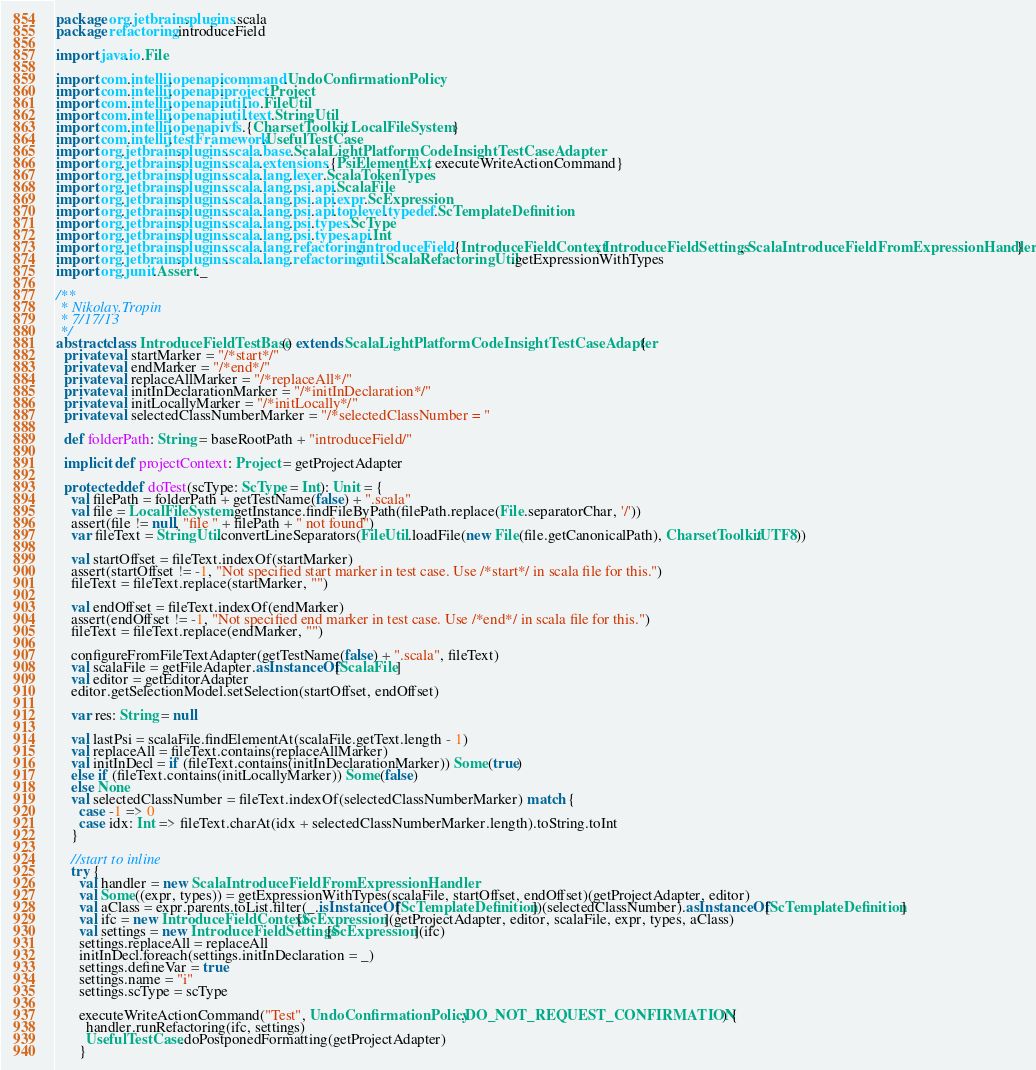Convert code to text. <code><loc_0><loc_0><loc_500><loc_500><_Scala_>package org.jetbrains.plugins.scala
package refactoring.introduceField

import java.io.File

import com.intellij.openapi.command.UndoConfirmationPolicy
import com.intellij.openapi.project.Project
import com.intellij.openapi.util.io.FileUtil
import com.intellij.openapi.util.text.StringUtil
import com.intellij.openapi.vfs.{CharsetToolkit, LocalFileSystem}
import com.intellij.testFramework.UsefulTestCase
import org.jetbrains.plugins.scala.base.ScalaLightPlatformCodeInsightTestCaseAdapter
import org.jetbrains.plugins.scala.extensions.{PsiElementExt, executeWriteActionCommand}
import org.jetbrains.plugins.scala.lang.lexer.ScalaTokenTypes
import org.jetbrains.plugins.scala.lang.psi.api.ScalaFile
import org.jetbrains.plugins.scala.lang.psi.api.expr.ScExpression
import org.jetbrains.plugins.scala.lang.psi.api.toplevel.typedef.ScTemplateDefinition
import org.jetbrains.plugins.scala.lang.psi.types.ScType
import org.jetbrains.plugins.scala.lang.psi.types.api.Int
import org.jetbrains.plugins.scala.lang.refactoring.introduceField.{IntroduceFieldContext, IntroduceFieldSettings, ScalaIntroduceFieldFromExpressionHandler}
import org.jetbrains.plugins.scala.lang.refactoring.util.ScalaRefactoringUtil.getExpressionWithTypes
import org.junit.Assert._

/**
 * Nikolay.Tropin
 * 7/17/13
 */
abstract class IntroduceFieldTestBase() extends ScalaLightPlatformCodeInsightTestCaseAdapter {
  private val startMarker = "/*start*/"
  private val endMarker = "/*end*/"
  private val replaceAllMarker = "/*replaceAll*/"
  private val initInDeclarationMarker = "/*initInDeclaration*/"
  private val initLocallyMarker = "/*initLocally*/"
  private val selectedClassNumberMarker = "/*selectedClassNumber = "

  def folderPath: String = baseRootPath + "introduceField/"

  implicit def projectContext: Project = getProjectAdapter

  protected def doTest(scType: ScType = Int): Unit = {
    val filePath = folderPath + getTestName(false) + ".scala"
    val file = LocalFileSystem.getInstance.findFileByPath(filePath.replace(File.separatorChar, '/'))
    assert(file != null, "file " + filePath + " not found")
    var fileText = StringUtil.convertLineSeparators(FileUtil.loadFile(new File(file.getCanonicalPath), CharsetToolkit.UTF8))

    val startOffset = fileText.indexOf(startMarker)
    assert(startOffset != -1, "Not specified start marker in test case. Use /*start*/ in scala file for this.")
    fileText = fileText.replace(startMarker, "")

    val endOffset = fileText.indexOf(endMarker)
    assert(endOffset != -1, "Not specified end marker in test case. Use /*end*/ in scala file for this.")
    fileText = fileText.replace(endMarker, "")

    configureFromFileTextAdapter(getTestName(false) + ".scala", fileText)
    val scalaFile = getFileAdapter.asInstanceOf[ScalaFile]
    val editor = getEditorAdapter
    editor.getSelectionModel.setSelection(startOffset, endOffset)

    var res: String = null

    val lastPsi = scalaFile.findElementAt(scalaFile.getText.length - 1)
    val replaceAll = fileText.contains(replaceAllMarker)
    val initInDecl = if (fileText.contains(initInDeclarationMarker)) Some(true)
    else if (fileText.contains(initLocallyMarker)) Some(false)
    else None
    val selectedClassNumber = fileText.indexOf(selectedClassNumberMarker) match {
      case -1 => 0
      case idx: Int => fileText.charAt(idx + selectedClassNumberMarker.length).toString.toInt
    }
    
    //start to inline
    try {
      val handler = new ScalaIntroduceFieldFromExpressionHandler
      val Some((expr, types)) = getExpressionWithTypes(scalaFile, startOffset, endOffset)(getProjectAdapter, editor)
      val aClass = expr.parents.toList.filter(_.isInstanceOf[ScTemplateDefinition])(selectedClassNumber).asInstanceOf[ScTemplateDefinition]
      val ifc = new IntroduceFieldContext[ScExpression](getProjectAdapter, editor, scalaFile, expr, types, aClass)
      val settings = new IntroduceFieldSettings[ScExpression](ifc)
      settings.replaceAll = replaceAll
      initInDecl.foreach(settings.initInDeclaration = _)
      settings.defineVar = true
      settings.name = "i"
      settings.scType = scType

      executeWriteActionCommand("Test", UndoConfirmationPolicy.DO_NOT_REQUEST_CONFIRMATION) {
        handler.runRefactoring(ifc, settings)
        UsefulTestCase.doPostponedFormatting(getProjectAdapter)
      }
</code> 